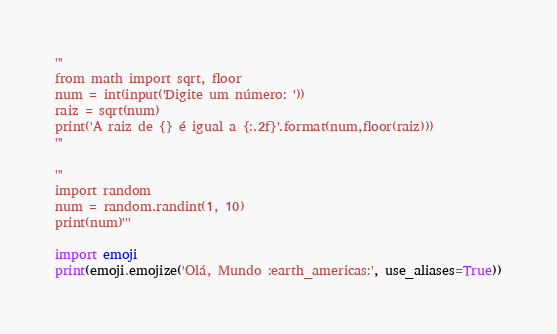Convert code to text. <code><loc_0><loc_0><loc_500><loc_500><_Python_>'''
from math import sqrt, floor
num = int(input('Digite um número: '))
raiz = sqrt(num)
print('A raiz de {} é igual a {:.2f}'.format(num,floor(raiz)))
'''

'''
import random
num = random.randint(1, 10)
print(num)'''

import emoji
print(emoji.emojize('Olá, Mundo :earth_americas:', use_aliases=True))</code> 